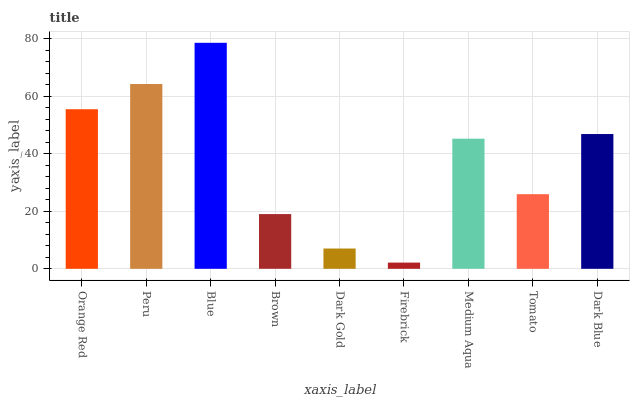Is Firebrick the minimum?
Answer yes or no. Yes. Is Blue the maximum?
Answer yes or no. Yes. Is Peru the minimum?
Answer yes or no. No. Is Peru the maximum?
Answer yes or no. No. Is Peru greater than Orange Red?
Answer yes or no. Yes. Is Orange Red less than Peru?
Answer yes or no. Yes. Is Orange Red greater than Peru?
Answer yes or no. No. Is Peru less than Orange Red?
Answer yes or no. No. Is Medium Aqua the high median?
Answer yes or no. Yes. Is Medium Aqua the low median?
Answer yes or no. Yes. Is Firebrick the high median?
Answer yes or no. No. Is Blue the low median?
Answer yes or no. No. 